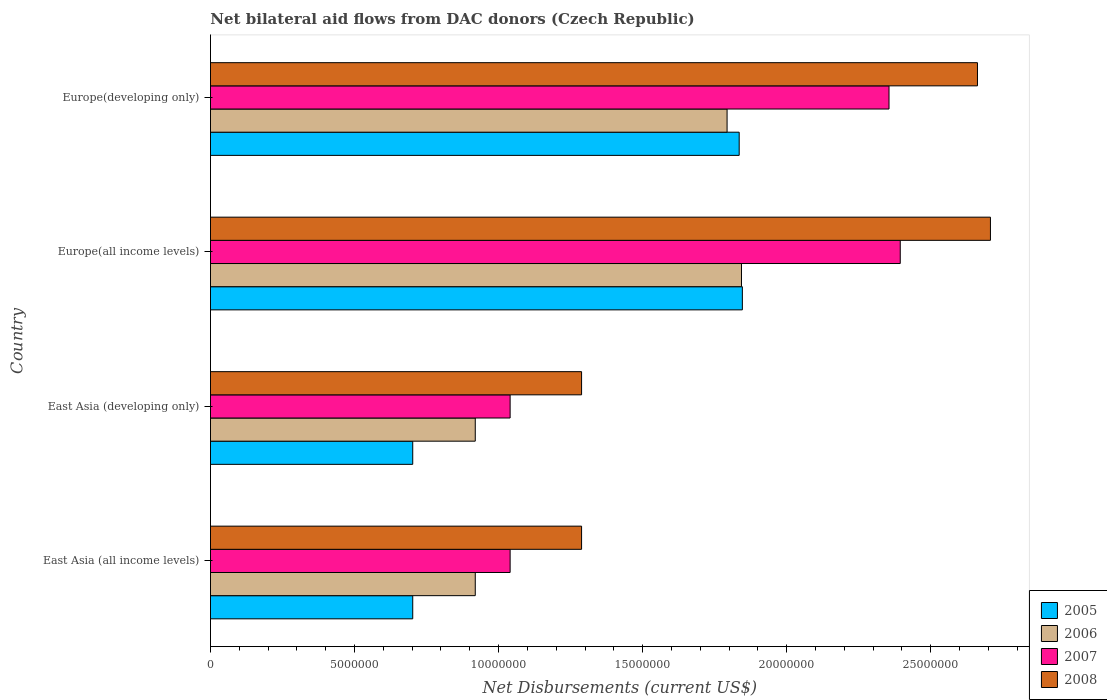Are the number of bars per tick equal to the number of legend labels?
Give a very brief answer. Yes. What is the label of the 1st group of bars from the top?
Ensure brevity in your answer.  Europe(developing only). What is the net bilateral aid flows in 2007 in Europe(all income levels)?
Your answer should be very brief. 2.39e+07. Across all countries, what is the maximum net bilateral aid flows in 2005?
Ensure brevity in your answer.  1.85e+07. Across all countries, what is the minimum net bilateral aid flows in 2007?
Your response must be concise. 1.04e+07. In which country was the net bilateral aid flows in 2005 maximum?
Keep it short and to the point. Europe(all income levels). In which country was the net bilateral aid flows in 2008 minimum?
Give a very brief answer. East Asia (all income levels). What is the total net bilateral aid flows in 2005 in the graph?
Ensure brevity in your answer.  5.08e+07. What is the difference between the net bilateral aid flows in 2008 in East Asia (developing only) and that in Europe(developing only)?
Provide a short and direct response. -1.37e+07. What is the difference between the net bilateral aid flows in 2008 in East Asia (all income levels) and the net bilateral aid flows in 2005 in Europe(all income levels)?
Ensure brevity in your answer.  -5.58e+06. What is the average net bilateral aid flows in 2005 per country?
Your answer should be compact. 1.27e+07. What is the difference between the net bilateral aid flows in 2005 and net bilateral aid flows in 2007 in East Asia (all income levels)?
Keep it short and to the point. -3.38e+06. What is the ratio of the net bilateral aid flows in 2005 in East Asia (all income levels) to that in Europe(developing only)?
Provide a short and direct response. 0.38. Is the difference between the net bilateral aid flows in 2005 in East Asia (developing only) and Europe(developing only) greater than the difference between the net bilateral aid flows in 2007 in East Asia (developing only) and Europe(developing only)?
Offer a terse response. Yes. What is the difference between the highest and the second highest net bilateral aid flows in 2006?
Provide a succinct answer. 5.00e+05. What is the difference between the highest and the lowest net bilateral aid flows in 2006?
Make the answer very short. 9.24e+06. In how many countries, is the net bilateral aid flows in 2007 greater than the average net bilateral aid flows in 2007 taken over all countries?
Offer a terse response. 2. Is the sum of the net bilateral aid flows in 2007 in East Asia (developing only) and Europe(developing only) greater than the maximum net bilateral aid flows in 2006 across all countries?
Give a very brief answer. Yes. What does the 4th bar from the top in East Asia (all income levels) represents?
Your response must be concise. 2005. Is it the case that in every country, the sum of the net bilateral aid flows in 2007 and net bilateral aid flows in 2008 is greater than the net bilateral aid flows in 2006?
Your answer should be compact. Yes. How many countries are there in the graph?
Your answer should be very brief. 4. Are the values on the major ticks of X-axis written in scientific E-notation?
Your answer should be compact. No. Does the graph contain any zero values?
Give a very brief answer. No. Does the graph contain grids?
Provide a succinct answer. No. Where does the legend appear in the graph?
Offer a terse response. Bottom right. What is the title of the graph?
Offer a terse response. Net bilateral aid flows from DAC donors (Czech Republic). What is the label or title of the X-axis?
Offer a terse response. Net Disbursements (current US$). What is the Net Disbursements (current US$) of 2005 in East Asia (all income levels)?
Give a very brief answer. 7.02e+06. What is the Net Disbursements (current US$) of 2006 in East Asia (all income levels)?
Make the answer very short. 9.19e+06. What is the Net Disbursements (current US$) in 2007 in East Asia (all income levels)?
Offer a terse response. 1.04e+07. What is the Net Disbursements (current US$) of 2008 in East Asia (all income levels)?
Keep it short and to the point. 1.29e+07. What is the Net Disbursements (current US$) of 2005 in East Asia (developing only)?
Offer a terse response. 7.02e+06. What is the Net Disbursements (current US$) in 2006 in East Asia (developing only)?
Keep it short and to the point. 9.19e+06. What is the Net Disbursements (current US$) in 2007 in East Asia (developing only)?
Provide a short and direct response. 1.04e+07. What is the Net Disbursements (current US$) in 2008 in East Asia (developing only)?
Offer a terse response. 1.29e+07. What is the Net Disbursements (current US$) in 2005 in Europe(all income levels)?
Provide a succinct answer. 1.85e+07. What is the Net Disbursements (current US$) of 2006 in Europe(all income levels)?
Keep it short and to the point. 1.84e+07. What is the Net Disbursements (current US$) in 2007 in Europe(all income levels)?
Ensure brevity in your answer.  2.39e+07. What is the Net Disbursements (current US$) of 2008 in Europe(all income levels)?
Provide a succinct answer. 2.71e+07. What is the Net Disbursements (current US$) of 2005 in Europe(developing only)?
Ensure brevity in your answer.  1.84e+07. What is the Net Disbursements (current US$) of 2006 in Europe(developing only)?
Provide a short and direct response. 1.79e+07. What is the Net Disbursements (current US$) in 2007 in Europe(developing only)?
Offer a very short reply. 2.36e+07. What is the Net Disbursements (current US$) of 2008 in Europe(developing only)?
Provide a short and direct response. 2.66e+07. Across all countries, what is the maximum Net Disbursements (current US$) in 2005?
Ensure brevity in your answer.  1.85e+07. Across all countries, what is the maximum Net Disbursements (current US$) in 2006?
Keep it short and to the point. 1.84e+07. Across all countries, what is the maximum Net Disbursements (current US$) of 2007?
Provide a succinct answer. 2.39e+07. Across all countries, what is the maximum Net Disbursements (current US$) of 2008?
Your answer should be very brief. 2.71e+07. Across all countries, what is the minimum Net Disbursements (current US$) of 2005?
Your answer should be compact. 7.02e+06. Across all countries, what is the minimum Net Disbursements (current US$) of 2006?
Make the answer very short. 9.19e+06. Across all countries, what is the minimum Net Disbursements (current US$) of 2007?
Your answer should be very brief. 1.04e+07. Across all countries, what is the minimum Net Disbursements (current US$) in 2008?
Your response must be concise. 1.29e+07. What is the total Net Disbursements (current US$) in 2005 in the graph?
Make the answer very short. 5.08e+07. What is the total Net Disbursements (current US$) of 2006 in the graph?
Give a very brief answer. 5.47e+07. What is the total Net Disbursements (current US$) of 2007 in the graph?
Provide a short and direct response. 6.83e+07. What is the total Net Disbursements (current US$) in 2008 in the graph?
Your answer should be compact. 7.94e+07. What is the difference between the Net Disbursements (current US$) of 2005 in East Asia (all income levels) and that in East Asia (developing only)?
Ensure brevity in your answer.  0. What is the difference between the Net Disbursements (current US$) of 2007 in East Asia (all income levels) and that in East Asia (developing only)?
Your answer should be compact. 0. What is the difference between the Net Disbursements (current US$) of 2005 in East Asia (all income levels) and that in Europe(all income levels)?
Give a very brief answer. -1.14e+07. What is the difference between the Net Disbursements (current US$) of 2006 in East Asia (all income levels) and that in Europe(all income levels)?
Keep it short and to the point. -9.24e+06. What is the difference between the Net Disbursements (current US$) in 2007 in East Asia (all income levels) and that in Europe(all income levels)?
Offer a terse response. -1.35e+07. What is the difference between the Net Disbursements (current US$) in 2008 in East Asia (all income levels) and that in Europe(all income levels)?
Make the answer very short. -1.42e+07. What is the difference between the Net Disbursements (current US$) of 2005 in East Asia (all income levels) and that in Europe(developing only)?
Provide a short and direct response. -1.13e+07. What is the difference between the Net Disbursements (current US$) of 2006 in East Asia (all income levels) and that in Europe(developing only)?
Offer a very short reply. -8.74e+06. What is the difference between the Net Disbursements (current US$) in 2007 in East Asia (all income levels) and that in Europe(developing only)?
Your answer should be compact. -1.32e+07. What is the difference between the Net Disbursements (current US$) of 2008 in East Asia (all income levels) and that in Europe(developing only)?
Offer a very short reply. -1.37e+07. What is the difference between the Net Disbursements (current US$) of 2005 in East Asia (developing only) and that in Europe(all income levels)?
Your answer should be very brief. -1.14e+07. What is the difference between the Net Disbursements (current US$) in 2006 in East Asia (developing only) and that in Europe(all income levels)?
Ensure brevity in your answer.  -9.24e+06. What is the difference between the Net Disbursements (current US$) in 2007 in East Asia (developing only) and that in Europe(all income levels)?
Keep it short and to the point. -1.35e+07. What is the difference between the Net Disbursements (current US$) in 2008 in East Asia (developing only) and that in Europe(all income levels)?
Your answer should be compact. -1.42e+07. What is the difference between the Net Disbursements (current US$) in 2005 in East Asia (developing only) and that in Europe(developing only)?
Give a very brief answer. -1.13e+07. What is the difference between the Net Disbursements (current US$) of 2006 in East Asia (developing only) and that in Europe(developing only)?
Your response must be concise. -8.74e+06. What is the difference between the Net Disbursements (current US$) in 2007 in East Asia (developing only) and that in Europe(developing only)?
Your response must be concise. -1.32e+07. What is the difference between the Net Disbursements (current US$) in 2008 in East Asia (developing only) and that in Europe(developing only)?
Your answer should be very brief. -1.37e+07. What is the difference between the Net Disbursements (current US$) of 2005 in East Asia (all income levels) and the Net Disbursements (current US$) of 2006 in East Asia (developing only)?
Give a very brief answer. -2.17e+06. What is the difference between the Net Disbursements (current US$) of 2005 in East Asia (all income levels) and the Net Disbursements (current US$) of 2007 in East Asia (developing only)?
Your response must be concise. -3.38e+06. What is the difference between the Net Disbursements (current US$) in 2005 in East Asia (all income levels) and the Net Disbursements (current US$) in 2008 in East Asia (developing only)?
Provide a succinct answer. -5.86e+06. What is the difference between the Net Disbursements (current US$) in 2006 in East Asia (all income levels) and the Net Disbursements (current US$) in 2007 in East Asia (developing only)?
Provide a short and direct response. -1.21e+06. What is the difference between the Net Disbursements (current US$) in 2006 in East Asia (all income levels) and the Net Disbursements (current US$) in 2008 in East Asia (developing only)?
Your response must be concise. -3.69e+06. What is the difference between the Net Disbursements (current US$) in 2007 in East Asia (all income levels) and the Net Disbursements (current US$) in 2008 in East Asia (developing only)?
Your response must be concise. -2.48e+06. What is the difference between the Net Disbursements (current US$) of 2005 in East Asia (all income levels) and the Net Disbursements (current US$) of 2006 in Europe(all income levels)?
Provide a succinct answer. -1.14e+07. What is the difference between the Net Disbursements (current US$) in 2005 in East Asia (all income levels) and the Net Disbursements (current US$) in 2007 in Europe(all income levels)?
Your answer should be very brief. -1.69e+07. What is the difference between the Net Disbursements (current US$) in 2005 in East Asia (all income levels) and the Net Disbursements (current US$) in 2008 in Europe(all income levels)?
Offer a very short reply. -2.00e+07. What is the difference between the Net Disbursements (current US$) in 2006 in East Asia (all income levels) and the Net Disbursements (current US$) in 2007 in Europe(all income levels)?
Your answer should be very brief. -1.48e+07. What is the difference between the Net Disbursements (current US$) of 2006 in East Asia (all income levels) and the Net Disbursements (current US$) of 2008 in Europe(all income levels)?
Offer a very short reply. -1.79e+07. What is the difference between the Net Disbursements (current US$) in 2007 in East Asia (all income levels) and the Net Disbursements (current US$) in 2008 in Europe(all income levels)?
Ensure brevity in your answer.  -1.67e+07. What is the difference between the Net Disbursements (current US$) of 2005 in East Asia (all income levels) and the Net Disbursements (current US$) of 2006 in Europe(developing only)?
Provide a succinct answer. -1.09e+07. What is the difference between the Net Disbursements (current US$) of 2005 in East Asia (all income levels) and the Net Disbursements (current US$) of 2007 in Europe(developing only)?
Make the answer very short. -1.65e+07. What is the difference between the Net Disbursements (current US$) of 2005 in East Asia (all income levels) and the Net Disbursements (current US$) of 2008 in Europe(developing only)?
Provide a short and direct response. -1.96e+07. What is the difference between the Net Disbursements (current US$) of 2006 in East Asia (all income levels) and the Net Disbursements (current US$) of 2007 in Europe(developing only)?
Offer a terse response. -1.44e+07. What is the difference between the Net Disbursements (current US$) in 2006 in East Asia (all income levels) and the Net Disbursements (current US$) in 2008 in Europe(developing only)?
Offer a terse response. -1.74e+07. What is the difference between the Net Disbursements (current US$) in 2007 in East Asia (all income levels) and the Net Disbursements (current US$) in 2008 in Europe(developing only)?
Offer a terse response. -1.62e+07. What is the difference between the Net Disbursements (current US$) in 2005 in East Asia (developing only) and the Net Disbursements (current US$) in 2006 in Europe(all income levels)?
Provide a succinct answer. -1.14e+07. What is the difference between the Net Disbursements (current US$) in 2005 in East Asia (developing only) and the Net Disbursements (current US$) in 2007 in Europe(all income levels)?
Your answer should be compact. -1.69e+07. What is the difference between the Net Disbursements (current US$) of 2005 in East Asia (developing only) and the Net Disbursements (current US$) of 2008 in Europe(all income levels)?
Keep it short and to the point. -2.00e+07. What is the difference between the Net Disbursements (current US$) of 2006 in East Asia (developing only) and the Net Disbursements (current US$) of 2007 in Europe(all income levels)?
Ensure brevity in your answer.  -1.48e+07. What is the difference between the Net Disbursements (current US$) in 2006 in East Asia (developing only) and the Net Disbursements (current US$) in 2008 in Europe(all income levels)?
Ensure brevity in your answer.  -1.79e+07. What is the difference between the Net Disbursements (current US$) in 2007 in East Asia (developing only) and the Net Disbursements (current US$) in 2008 in Europe(all income levels)?
Offer a very short reply. -1.67e+07. What is the difference between the Net Disbursements (current US$) of 2005 in East Asia (developing only) and the Net Disbursements (current US$) of 2006 in Europe(developing only)?
Offer a very short reply. -1.09e+07. What is the difference between the Net Disbursements (current US$) of 2005 in East Asia (developing only) and the Net Disbursements (current US$) of 2007 in Europe(developing only)?
Your answer should be compact. -1.65e+07. What is the difference between the Net Disbursements (current US$) of 2005 in East Asia (developing only) and the Net Disbursements (current US$) of 2008 in Europe(developing only)?
Keep it short and to the point. -1.96e+07. What is the difference between the Net Disbursements (current US$) in 2006 in East Asia (developing only) and the Net Disbursements (current US$) in 2007 in Europe(developing only)?
Offer a terse response. -1.44e+07. What is the difference between the Net Disbursements (current US$) in 2006 in East Asia (developing only) and the Net Disbursements (current US$) in 2008 in Europe(developing only)?
Ensure brevity in your answer.  -1.74e+07. What is the difference between the Net Disbursements (current US$) of 2007 in East Asia (developing only) and the Net Disbursements (current US$) of 2008 in Europe(developing only)?
Your response must be concise. -1.62e+07. What is the difference between the Net Disbursements (current US$) of 2005 in Europe(all income levels) and the Net Disbursements (current US$) of 2006 in Europe(developing only)?
Your answer should be compact. 5.30e+05. What is the difference between the Net Disbursements (current US$) in 2005 in Europe(all income levels) and the Net Disbursements (current US$) in 2007 in Europe(developing only)?
Your answer should be very brief. -5.09e+06. What is the difference between the Net Disbursements (current US$) of 2005 in Europe(all income levels) and the Net Disbursements (current US$) of 2008 in Europe(developing only)?
Make the answer very short. -8.16e+06. What is the difference between the Net Disbursements (current US$) of 2006 in Europe(all income levels) and the Net Disbursements (current US$) of 2007 in Europe(developing only)?
Your answer should be very brief. -5.12e+06. What is the difference between the Net Disbursements (current US$) in 2006 in Europe(all income levels) and the Net Disbursements (current US$) in 2008 in Europe(developing only)?
Make the answer very short. -8.19e+06. What is the difference between the Net Disbursements (current US$) of 2007 in Europe(all income levels) and the Net Disbursements (current US$) of 2008 in Europe(developing only)?
Offer a terse response. -2.68e+06. What is the average Net Disbursements (current US$) of 2005 per country?
Your answer should be compact. 1.27e+07. What is the average Net Disbursements (current US$) in 2006 per country?
Ensure brevity in your answer.  1.37e+07. What is the average Net Disbursements (current US$) in 2007 per country?
Your answer should be compact. 1.71e+07. What is the average Net Disbursements (current US$) of 2008 per country?
Make the answer very short. 1.99e+07. What is the difference between the Net Disbursements (current US$) in 2005 and Net Disbursements (current US$) in 2006 in East Asia (all income levels)?
Keep it short and to the point. -2.17e+06. What is the difference between the Net Disbursements (current US$) of 2005 and Net Disbursements (current US$) of 2007 in East Asia (all income levels)?
Ensure brevity in your answer.  -3.38e+06. What is the difference between the Net Disbursements (current US$) of 2005 and Net Disbursements (current US$) of 2008 in East Asia (all income levels)?
Offer a very short reply. -5.86e+06. What is the difference between the Net Disbursements (current US$) of 2006 and Net Disbursements (current US$) of 2007 in East Asia (all income levels)?
Your response must be concise. -1.21e+06. What is the difference between the Net Disbursements (current US$) in 2006 and Net Disbursements (current US$) in 2008 in East Asia (all income levels)?
Make the answer very short. -3.69e+06. What is the difference between the Net Disbursements (current US$) in 2007 and Net Disbursements (current US$) in 2008 in East Asia (all income levels)?
Offer a terse response. -2.48e+06. What is the difference between the Net Disbursements (current US$) of 2005 and Net Disbursements (current US$) of 2006 in East Asia (developing only)?
Give a very brief answer. -2.17e+06. What is the difference between the Net Disbursements (current US$) of 2005 and Net Disbursements (current US$) of 2007 in East Asia (developing only)?
Ensure brevity in your answer.  -3.38e+06. What is the difference between the Net Disbursements (current US$) of 2005 and Net Disbursements (current US$) of 2008 in East Asia (developing only)?
Your answer should be compact. -5.86e+06. What is the difference between the Net Disbursements (current US$) in 2006 and Net Disbursements (current US$) in 2007 in East Asia (developing only)?
Give a very brief answer. -1.21e+06. What is the difference between the Net Disbursements (current US$) of 2006 and Net Disbursements (current US$) of 2008 in East Asia (developing only)?
Provide a short and direct response. -3.69e+06. What is the difference between the Net Disbursements (current US$) of 2007 and Net Disbursements (current US$) of 2008 in East Asia (developing only)?
Keep it short and to the point. -2.48e+06. What is the difference between the Net Disbursements (current US$) of 2005 and Net Disbursements (current US$) of 2007 in Europe(all income levels)?
Keep it short and to the point. -5.48e+06. What is the difference between the Net Disbursements (current US$) in 2005 and Net Disbursements (current US$) in 2008 in Europe(all income levels)?
Offer a very short reply. -8.61e+06. What is the difference between the Net Disbursements (current US$) in 2006 and Net Disbursements (current US$) in 2007 in Europe(all income levels)?
Your answer should be very brief. -5.51e+06. What is the difference between the Net Disbursements (current US$) of 2006 and Net Disbursements (current US$) of 2008 in Europe(all income levels)?
Keep it short and to the point. -8.64e+06. What is the difference between the Net Disbursements (current US$) of 2007 and Net Disbursements (current US$) of 2008 in Europe(all income levels)?
Offer a terse response. -3.13e+06. What is the difference between the Net Disbursements (current US$) in 2005 and Net Disbursements (current US$) in 2007 in Europe(developing only)?
Make the answer very short. -5.20e+06. What is the difference between the Net Disbursements (current US$) of 2005 and Net Disbursements (current US$) of 2008 in Europe(developing only)?
Ensure brevity in your answer.  -8.27e+06. What is the difference between the Net Disbursements (current US$) of 2006 and Net Disbursements (current US$) of 2007 in Europe(developing only)?
Ensure brevity in your answer.  -5.62e+06. What is the difference between the Net Disbursements (current US$) in 2006 and Net Disbursements (current US$) in 2008 in Europe(developing only)?
Your answer should be very brief. -8.69e+06. What is the difference between the Net Disbursements (current US$) of 2007 and Net Disbursements (current US$) of 2008 in Europe(developing only)?
Make the answer very short. -3.07e+06. What is the ratio of the Net Disbursements (current US$) of 2006 in East Asia (all income levels) to that in East Asia (developing only)?
Keep it short and to the point. 1. What is the ratio of the Net Disbursements (current US$) in 2007 in East Asia (all income levels) to that in East Asia (developing only)?
Offer a terse response. 1. What is the ratio of the Net Disbursements (current US$) of 2005 in East Asia (all income levels) to that in Europe(all income levels)?
Provide a short and direct response. 0.38. What is the ratio of the Net Disbursements (current US$) of 2006 in East Asia (all income levels) to that in Europe(all income levels)?
Provide a succinct answer. 0.5. What is the ratio of the Net Disbursements (current US$) of 2007 in East Asia (all income levels) to that in Europe(all income levels)?
Provide a succinct answer. 0.43. What is the ratio of the Net Disbursements (current US$) in 2008 in East Asia (all income levels) to that in Europe(all income levels)?
Offer a very short reply. 0.48. What is the ratio of the Net Disbursements (current US$) of 2005 in East Asia (all income levels) to that in Europe(developing only)?
Your answer should be compact. 0.38. What is the ratio of the Net Disbursements (current US$) of 2006 in East Asia (all income levels) to that in Europe(developing only)?
Make the answer very short. 0.51. What is the ratio of the Net Disbursements (current US$) in 2007 in East Asia (all income levels) to that in Europe(developing only)?
Offer a very short reply. 0.44. What is the ratio of the Net Disbursements (current US$) in 2008 in East Asia (all income levels) to that in Europe(developing only)?
Your answer should be compact. 0.48. What is the ratio of the Net Disbursements (current US$) in 2005 in East Asia (developing only) to that in Europe(all income levels)?
Provide a short and direct response. 0.38. What is the ratio of the Net Disbursements (current US$) of 2006 in East Asia (developing only) to that in Europe(all income levels)?
Offer a very short reply. 0.5. What is the ratio of the Net Disbursements (current US$) in 2007 in East Asia (developing only) to that in Europe(all income levels)?
Provide a succinct answer. 0.43. What is the ratio of the Net Disbursements (current US$) of 2008 in East Asia (developing only) to that in Europe(all income levels)?
Offer a very short reply. 0.48. What is the ratio of the Net Disbursements (current US$) of 2005 in East Asia (developing only) to that in Europe(developing only)?
Make the answer very short. 0.38. What is the ratio of the Net Disbursements (current US$) of 2006 in East Asia (developing only) to that in Europe(developing only)?
Offer a very short reply. 0.51. What is the ratio of the Net Disbursements (current US$) in 2007 in East Asia (developing only) to that in Europe(developing only)?
Your answer should be compact. 0.44. What is the ratio of the Net Disbursements (current US$) in 2008 in East Asia (developing only) to that in Europe(developing only)?
Provide a short and direct response. 0.48. What is the ratio of the Net Disbursements (current US$) in 2005 in Europe(all income levels) to that in Europe(developing only)?
Ensure brevity in your answer.  1.01. What is the ratio of the Net Disbursements (current US$) of 2006 in Europe(all income levels) to that in Europe(developing only)?
Provide a short and direct response. 1.03. What is the ratio of the Net Disbursements (current US$) of 2007 in Europe(all income levels) to that in Europe(developing only)?
Your answer should be very brief. 1.02. What is the ratio of the Net Disbursements (current US$) of 2008 in Europe(all income levels) to that in Europe(developing only)?
Offer a terse response. 1.02. What is the difference between the highest and the second highest Net Disbursements (current US$) of 2008?
Provide a succinct answer. 4.50e+05. What is the difference between the highest and the lowest Net Disbursements (current US$) of 2005?
Ensure brevity in your answer.  1.14e+07. What is the difference between the highest and the lowest Net Disbursements (current US$) in 2006?
Keep it short and to the point. 9.24e+06. What is the difference between the highest and the lowest Net Disbursements (current US$) in 2007?
Ensure brevity in your answer.  1.35e+07. What is the difference between the highest and the lowest Net Disbursements (current US$) of 2008?
Give a very brief answer. 1.42e+07. 